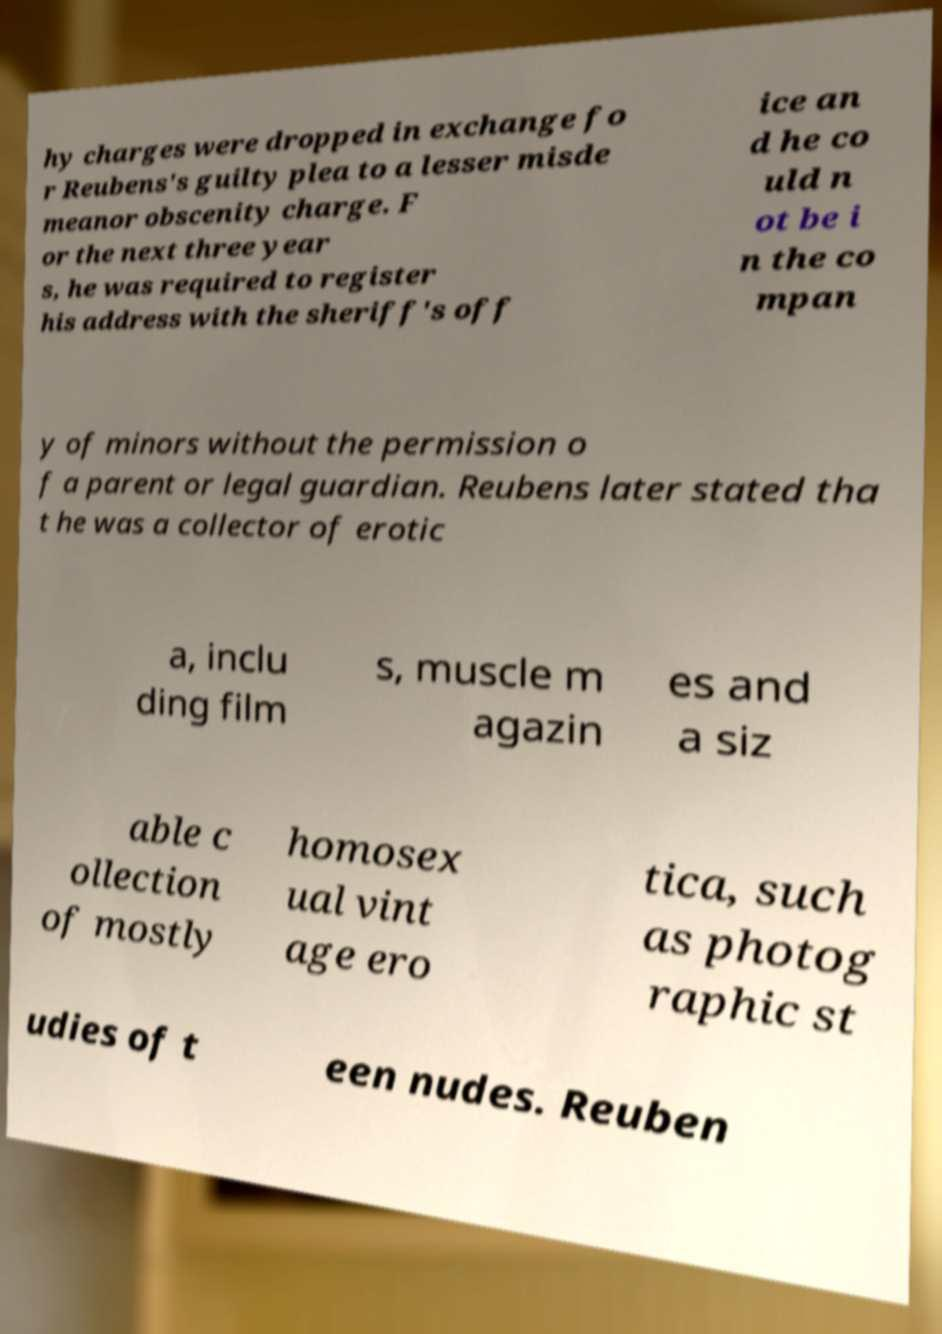Could you extract and type out the text from this image? hy charges were dropped in exchange fo r Reubens's guilty plea to a lesser misde meanor obscenity charge. F or the next three year s, he was required to register his address with the sheriff's off ice an d he co uld n ot be i n the co mpan y of minors without the permission o f a parent or legal guardian. Reubens later stated tha t he was a collector of erotic a, inclu ding film s, muscle m agazin es and a siz able c ollection of mostly homosex ual vint age ero tica, such as photog raphic st udies of t een nudes. Reuben 